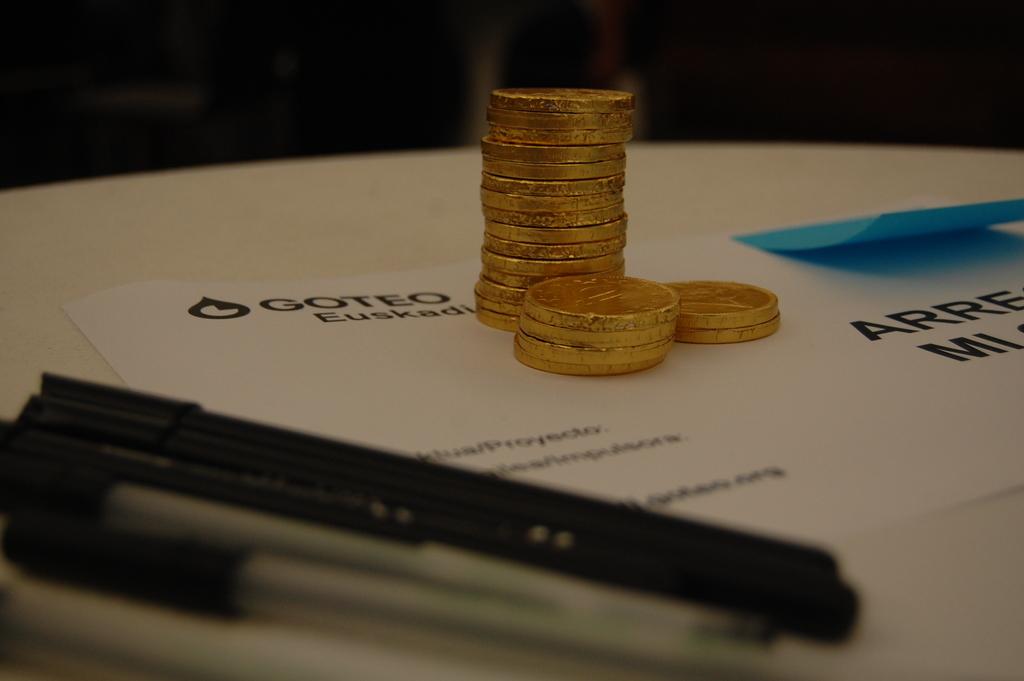What is the name of the company on the card?
Keep it short and to the point. Goteo. 